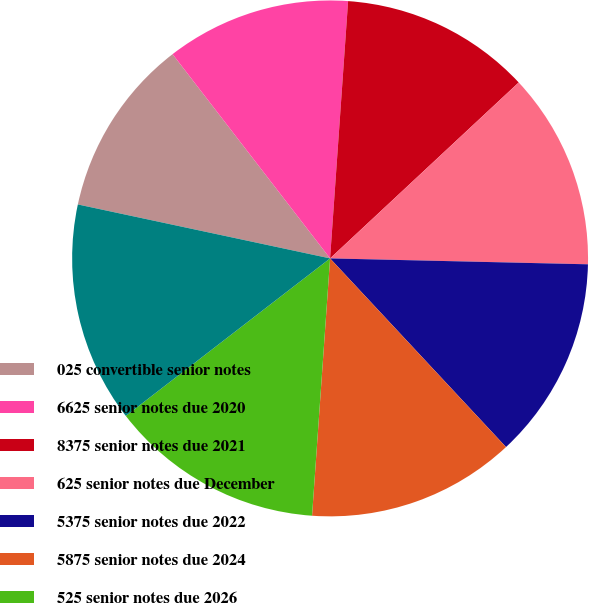<chart> <loc_0><loc_0><loc_500><loc_500><pie_chart><fcel>025 convertible senior notes<fcel>6625 senior notes due 2020<fcel>8375 senior notes due 2021<fcel>625 senior notes due December<fcel>5375 senior notes due 2022<fcel>5875 senior notes due 2024<fcel>525 senior notes due 2026<fcel>500 senior notes due 2027<nl><fcel>11.19%<fcel>11.57%<fcel>11.94%<fcel>12.31%<fcel>12.69%<fcel>13.06%<fcel>13.43%<fcel>13.81%<nl></chart> 